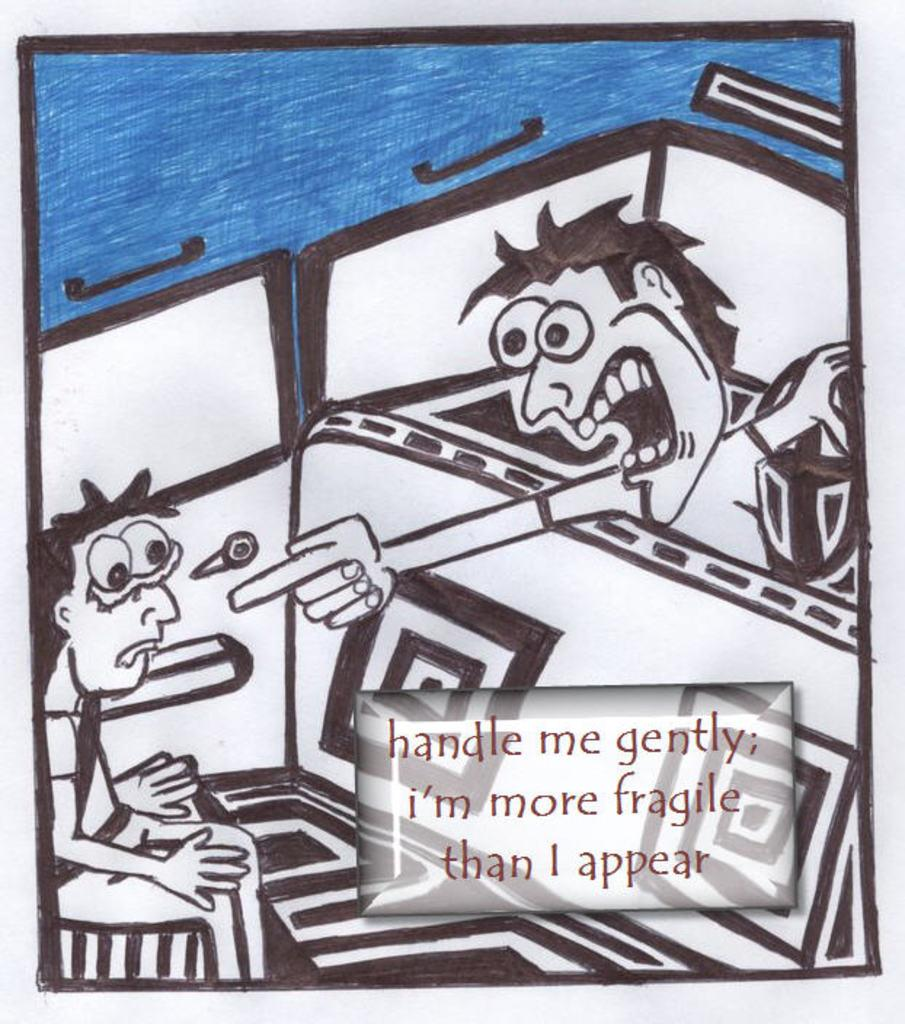<image>
Present a compact description of the photo's key features. Comic strip showing a man yelling at a boy and says "Handle me gently". 